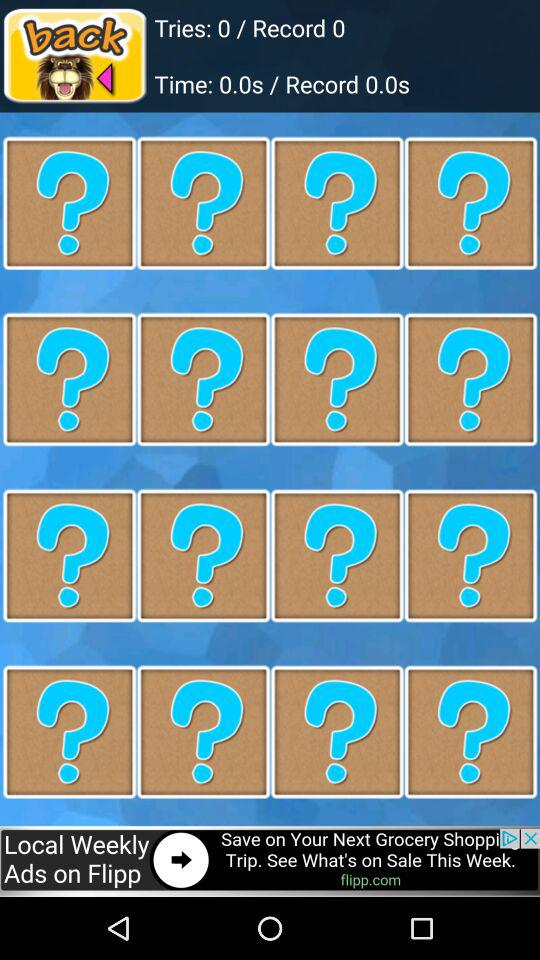What's the number of records? The number of records is 0. 